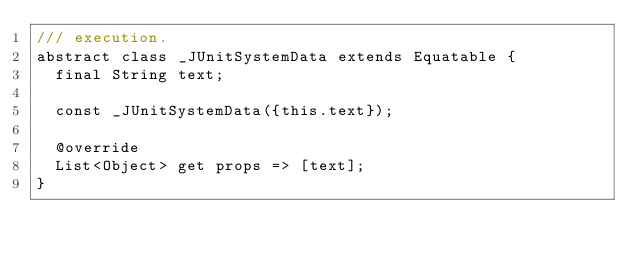<code> <loc_0><loc_0><loc_500><loc_500><_Dart_>/// execution.
abstract class _JUnitSystemData extends Equatable {
  final String text;

  const _JUnitSystemData({this.text});

  @override
  List<Object> get props => [text];
}
</code> 